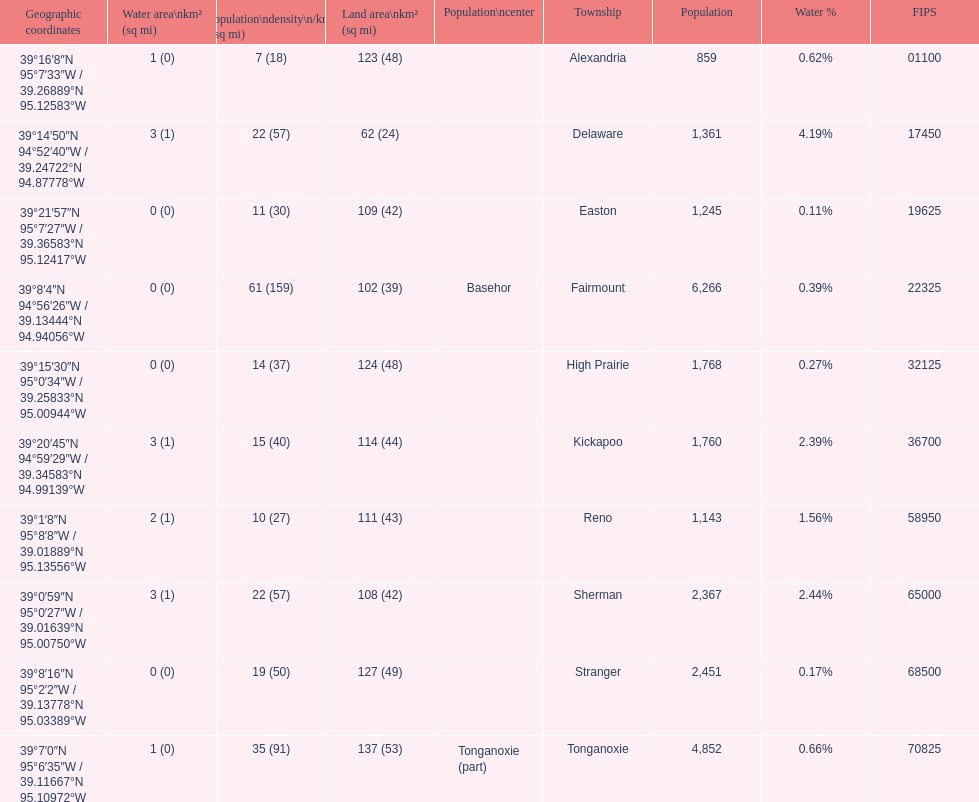Which township has the least land area? Delaware. 